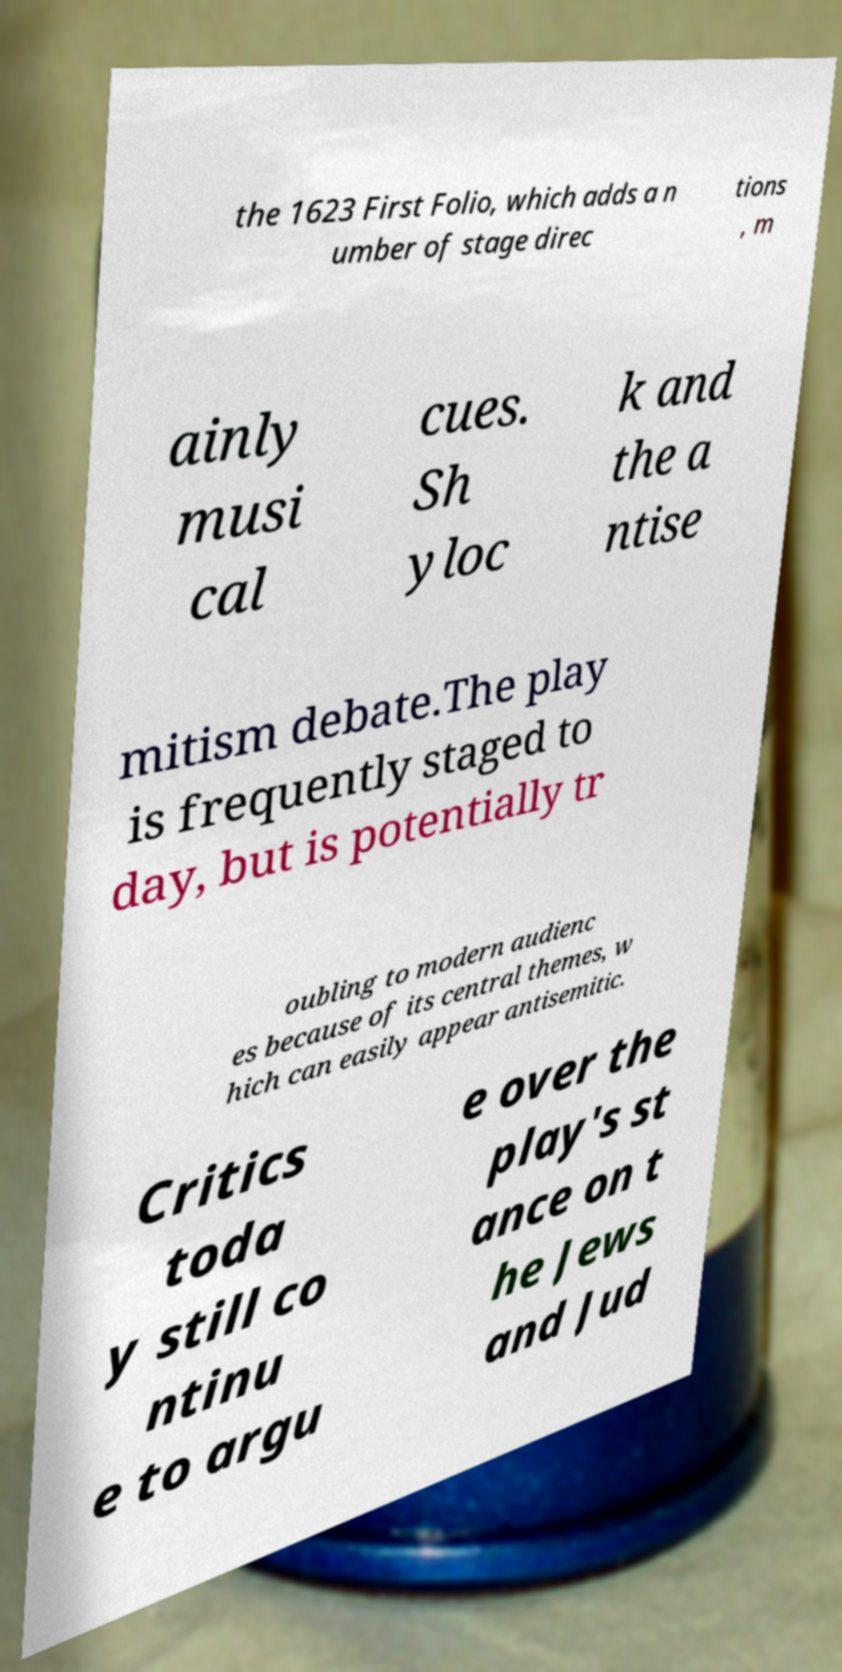Could you extract and type out the text from this image? the 1623 First Folio, which adds a n umber of stage direc tions , m ainly musi cal cues. Sh yloc k and the a ntise mitism debate.The play is frequently staged to day, but is potentially tr oubling to modern audienc es because of its central themes, w hich can easily appear antisemitic. Critics toda y still co ntinu e to argu e over the play's st ance on t he Jews and Jud 